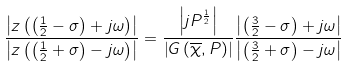<formula> <loc_0><loc_0><loc_500><loc_500>\frac { \left | z \left ( \left ( \frac { 1 } { 2 } - \sigma \right ) + j \omega \right ) \right | } { \left | z \left ( \left ( \frac { 1 } { 2 } + \sigma \right ) - j \omega \right ) \right | } = \frac { \left | j P ^ { \frac { 1 } { 2 } } \right | } { \left | G \left ( \overline { \chi } , P \right ) \right | } \frac { \left | \left ( \frac { 3 } { 2 } - \sigma \right ) + j \omega \right | } { \left | \left ( \frac { 3 } { 2 } + \sigma \right ) - j \omega \right | }</formula> 